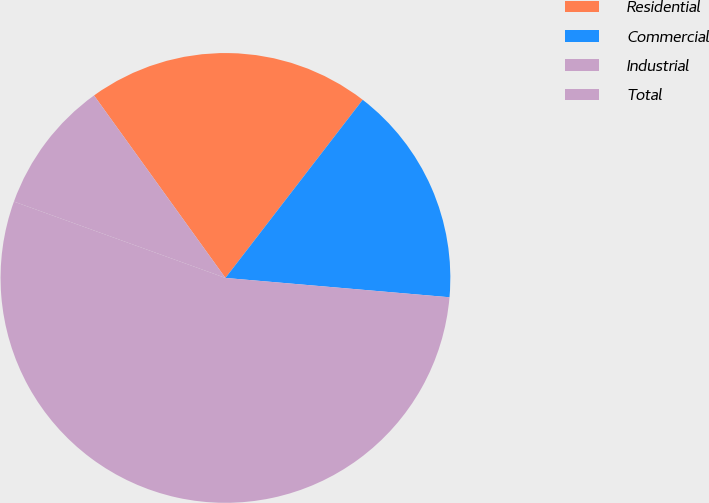Convert chart to OTSL. <chart><loc_0><loc_0><loc_500><loc_500><pie_chart><fcel>Residential<fcel>Commercial<fcel>Industrial<fcel>Total<nl><fcel>20.38%<fcel>15.92%<fcel>54.14%<fcel>9.55%<nl></chart> 